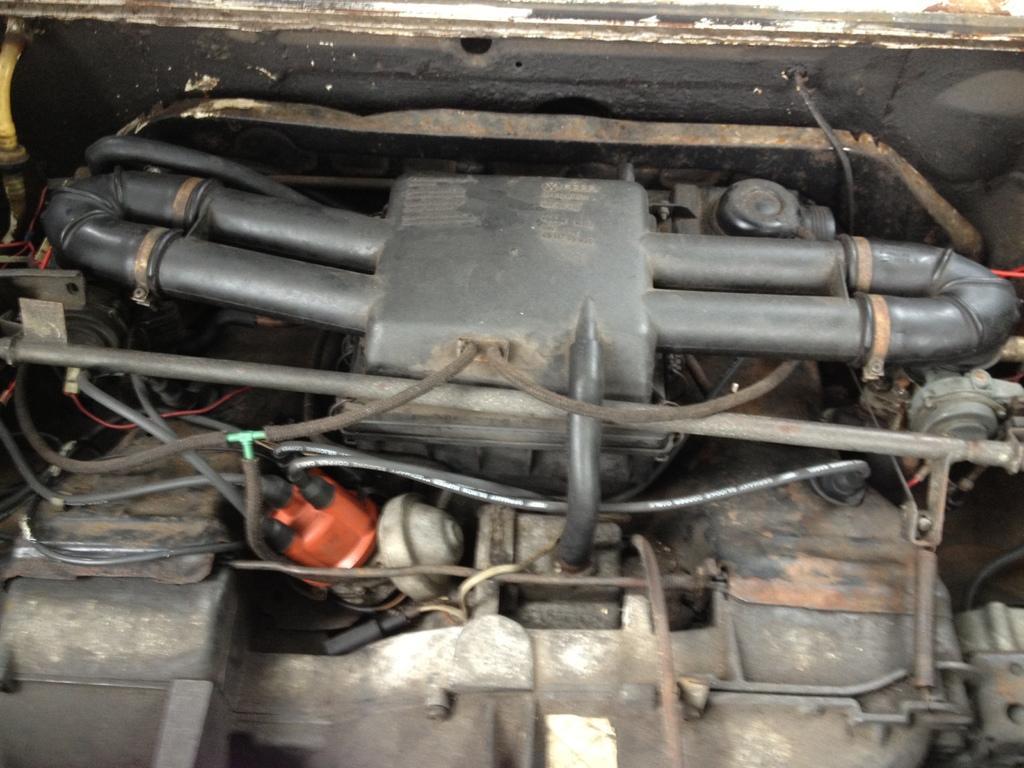Can you describe this image briefly? In this image we can see the machine parts of car. 